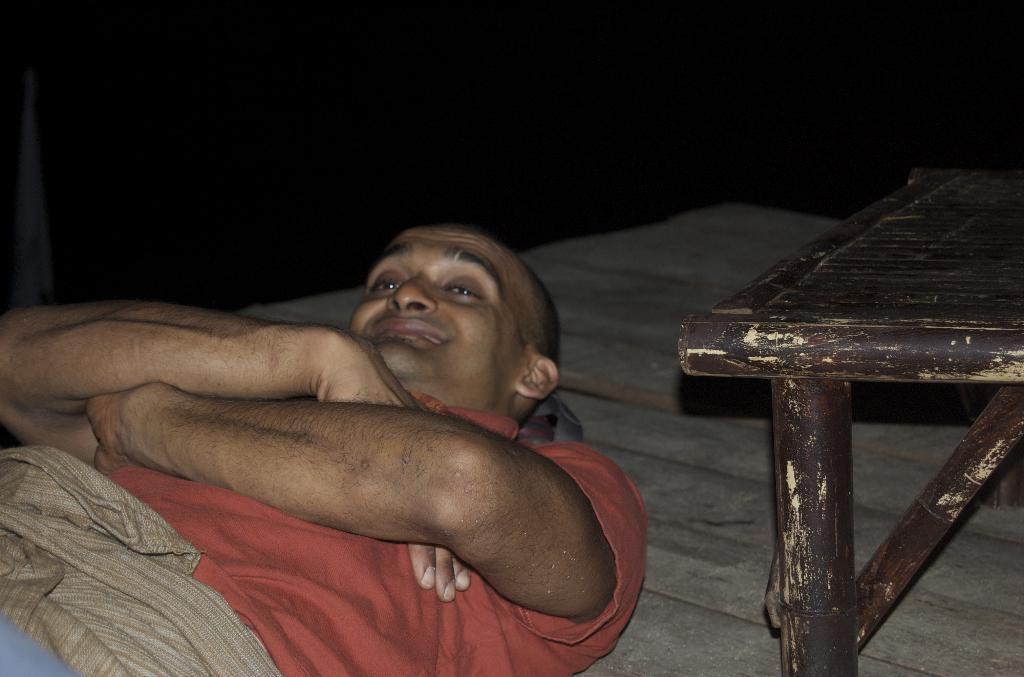Could you give a brief overview of what you see in this image? In this image there is a man lying on the floor. In the right side of the image there is a table made of wood. 